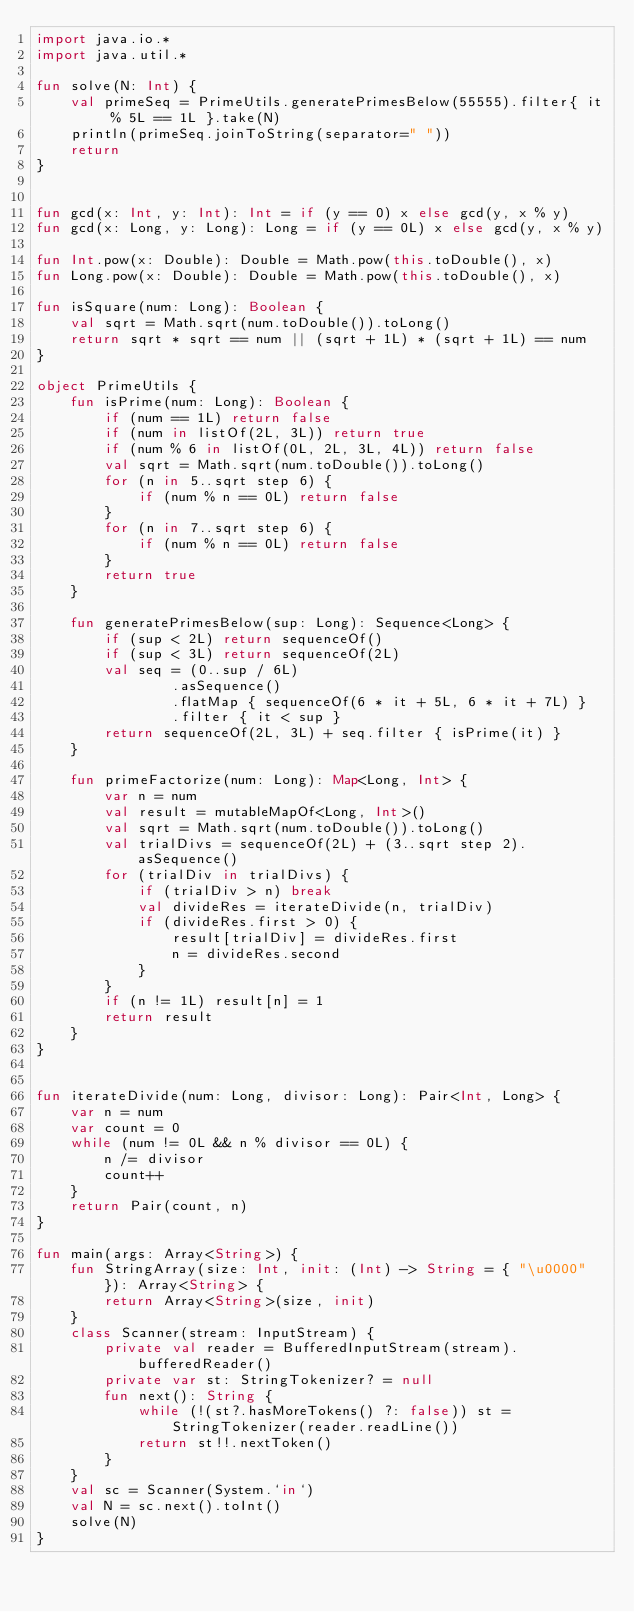Convert code to text. <code><loc_0><loc_0><loc_500><loc_500><_Kotlin_>import java.io.*
import java.util.*

fun solve(N: Int) {
    val primeSeq = PrimeUtils.generatePrimesBelow(55555).filter{ it % 5L == 1L }.take(N)
    println(primeSeq.joinToString(separator=" "))
    return
}


fun gcd(x: Int, y: Int): Int = if (y == 0) x else gcd(y, x % y)
fun gcd(x: Long, y: Long): Long = if (y == 0L) x else gcd(y, x % y)

fun Int.pow(x: Double): Double = Math.pow(this.toDouble(), x)
fun Long.pow(x: Double): Double = Math.pow(this.toDouble(), x)

fun isSquare(num: Long): Boolean {
    val sqrt = Math.sqrt(num.toDouble()).toLong()
    return sqrt * sqrt == num || (sqrt + 1L) * (sqrt + 1L) == num
}

object PrimeUtils {
    fun isPrime(num: Long): Boolean {
        if (num == 1L) return false
        if (num in listOf(2L, 3L)) return true
        if (num % 6 in listOf(0L, 2L, 3L, 4L)) return false
        val sqrt = Math.sqrt(num.toDouble()).toLong()
        for (n in 5..sqrt step 6) {
            if (num % n == 0L) return false
        }
        for (n in 7..sqrt step 6) {
            if (num % n == 0L) return false
        }
        return true
    }

    fun generatePrimesBelow(sup: Long): Sequence<Long> {
        if (sup < 2L) return sequenceOf()
        if (sup < 3L) return sequenceOf(2L)
        val seq = (0..sup / 6L)
                .asSequence()
                .flatMap { sequenceOf(6 * it + 5L, 6 * it + 7L) }
                .filter { it < sup }
        return sequenceOf(2L, 3L) + seq.filter { isPrime(it) }
    }

    fun primeFactorize(num: Long): Map<Long, Int> {
        var n = num
        val result = mutableMapOf<Long, Int>()
        val sqrt = Math.sqrt(num.toDouble()).toLong()
        val trialDivs = sequenceOf(2L) + (3..sqrt step 2).asSequence()
        for (trialDiv in trialDivs) {
            if (trialDiv > n) break
            val divideRes = iterateDivide(n, trialDiv)
            if (divideRes.first > 0) {
                result[trialDiv] = divideRes.first
                n = divideRes.second
            }
        }
        if (n != 1L) result[n] = 1
        return result
    }
}


fun iterateDivide(num: Long, divisor: Long): Pair<Int, Long> {
    var n = num
    var count = 0
    while (num != 0L && n % divisor == 0L) {
        n /= divisor
        count++
    }
    return Pair(count, n)
}

fun main(args: Array<String>) {
    fun StringArray(size: Int, init: (Int) -> String = { "\u0000" }): Array<String> {
        return Array<String>(size, init)
    }
    class Scanner(stream: InputStream) {
        private val reader = BufferedInputStream(stream).bufferedReader()
        private var st: StringTokenizer? = null
        fun next(): String {
            while (!(st?.hasMoreTokens() ?: false)) st = StringTokenizer(reader.readLine())
            return st!!.nextToken()
        }
    }
    val sc = Scanner(System.`in`)
    val N = sc.next().toInt()
    solve(N)
}
</code> 